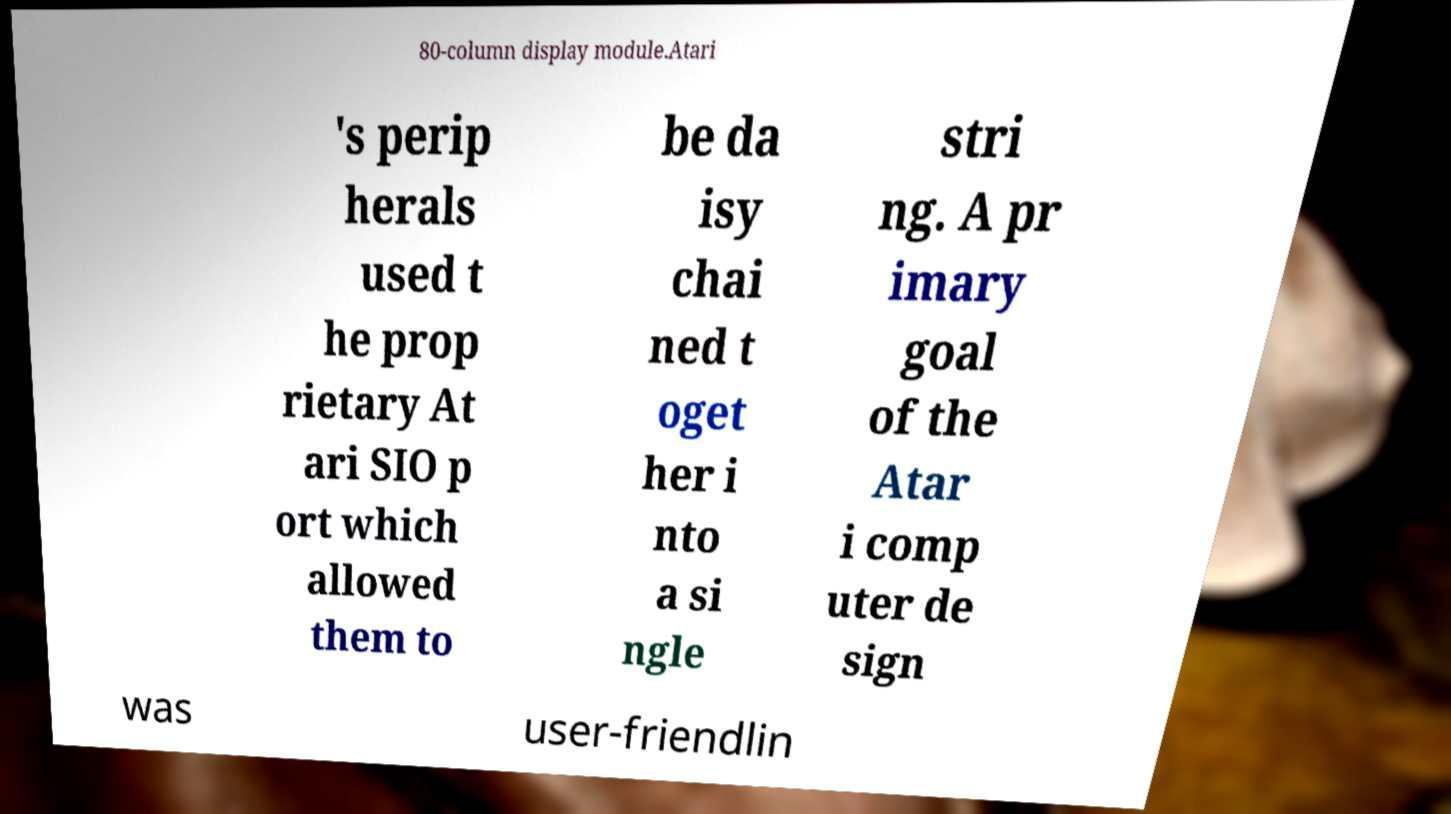I need the written content from this picture converted into text. Can you do that? 80-column display module.Atari 's perip herals used t he prop rietary At ari SIO p ort which allowed them to be da isy chai ned t oget her i nto a si ngle stri ng. A pr imary goal of the Atar i comp uter de sign was user-friendlin 